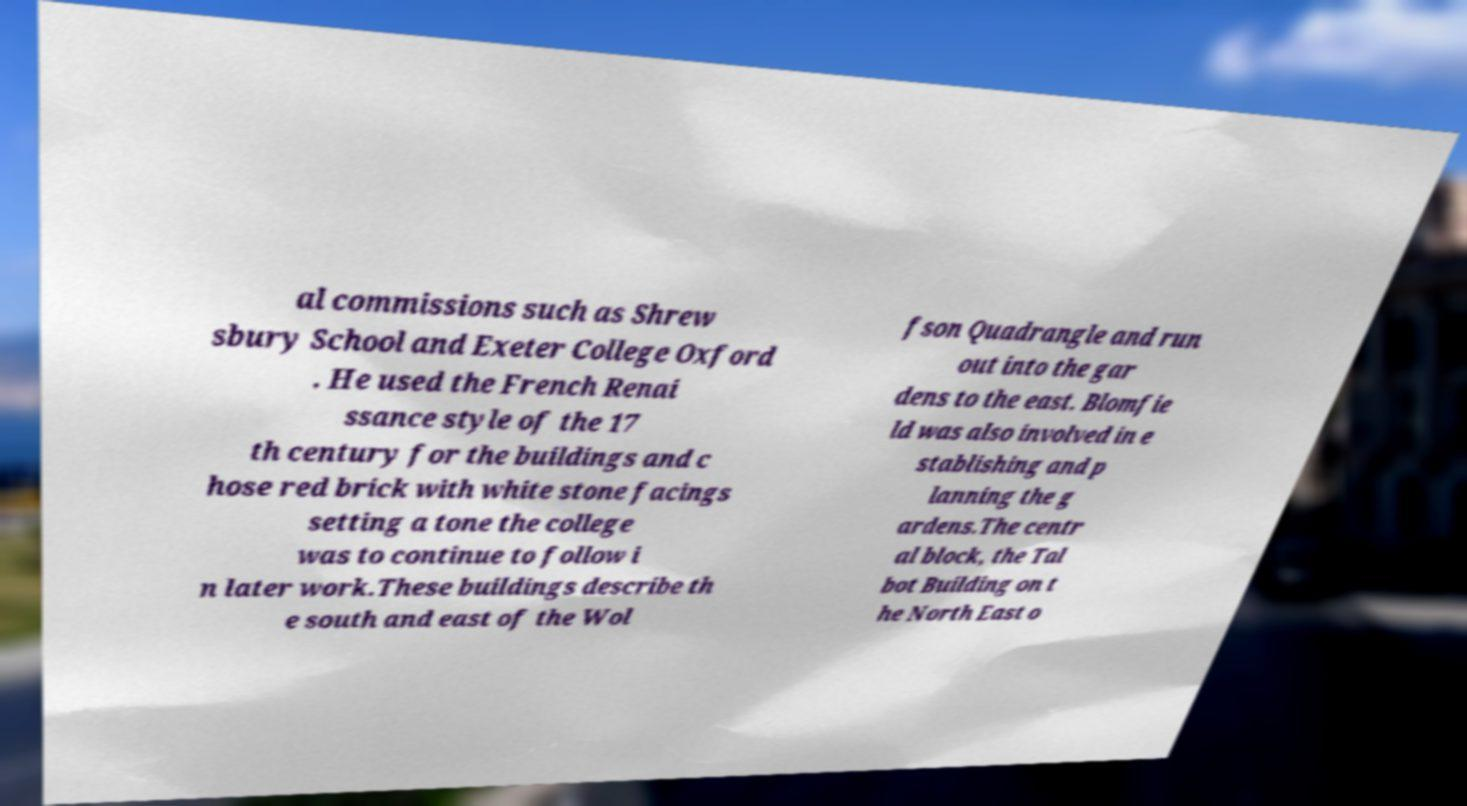Can you accurately transcribe the text from the provided image for me? al commissions such as Shrew sbury School and Exeter College Oxford . He used the French Renai ssance style of the 17 th century for the buildings and c hose red brick with white stone facings setting a tone the college was to continue to follow i n later work.These buildings describe th e south and east of the Wol fson Quadrangle and run out into the gar dens to the east. Blomfie ld was also involved in e stablishing and p lanning the g ardens.The centr al block, the Tal bot Building on t he North East o 